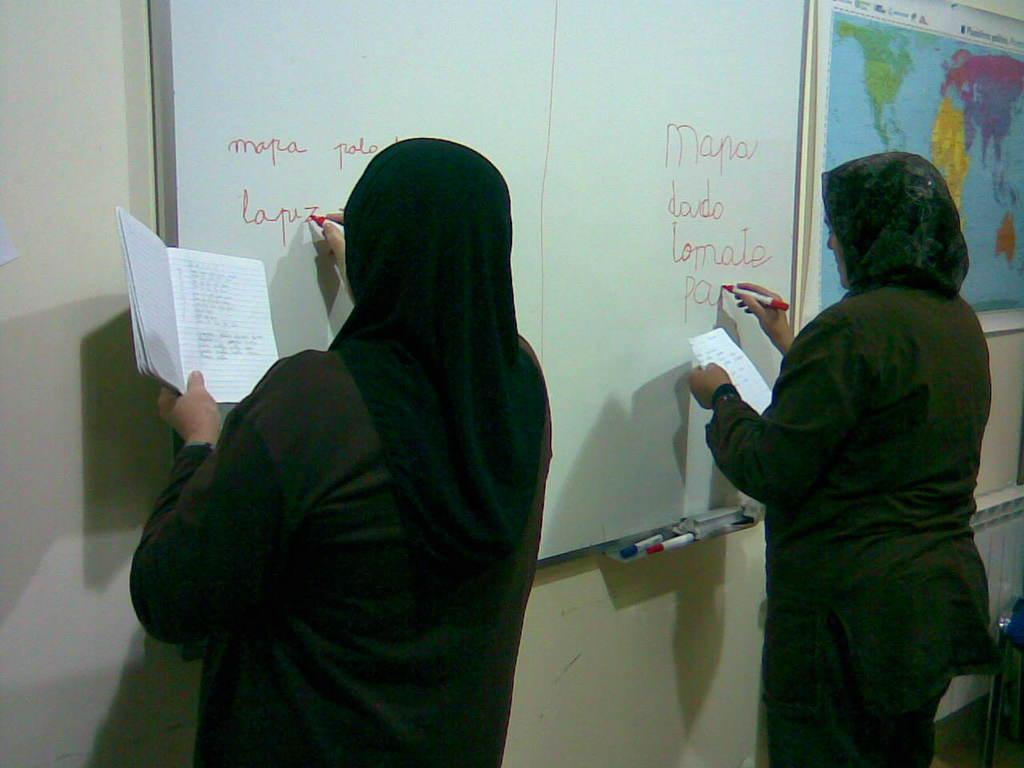How many people are present in the image? There are two people in the image. What are the people doing in the image? The people are writing on a whiteboard. What are the people holding in the image? The people are holding objects, but the specific objects are not mentioned in the facts. What can be seen on the wall in the image? There is a map on the wall in the image. What other unspecified objects are present in the image? There are other unspecified objects in the image, but their nature is not mentioned in the facts. What type of drug can be seen in the hands of the people in the image? There is no mention of any drug in the image or the facts provided. 